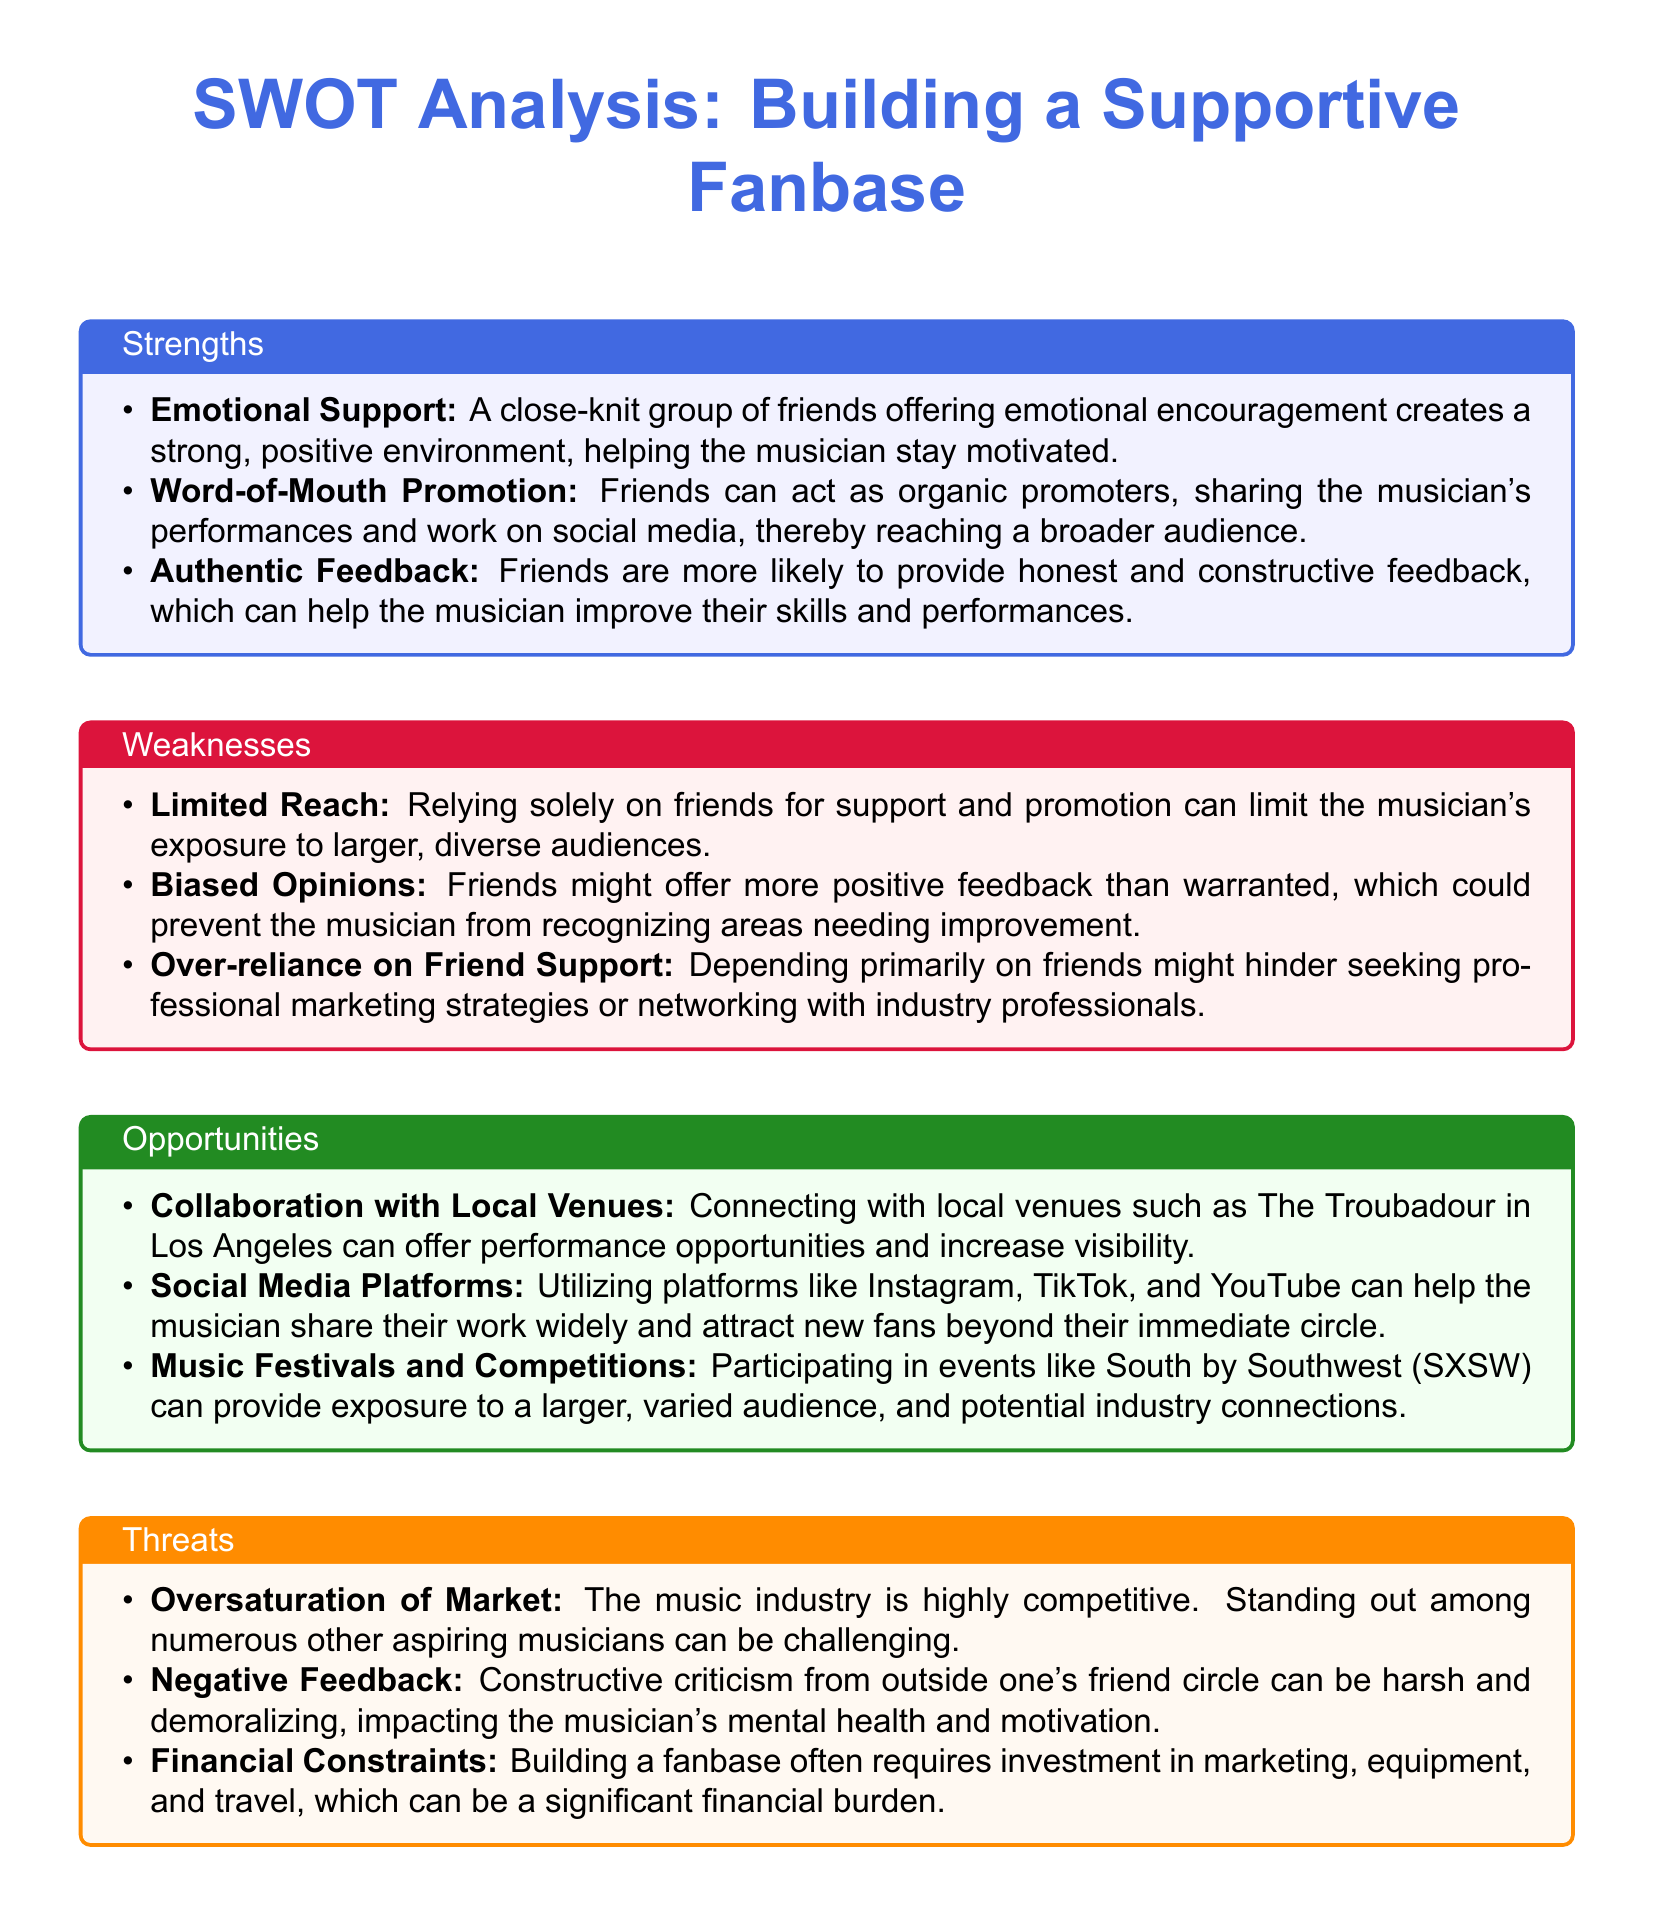What is one opportunity for building a supportive fanbase? The document lists several opportunities, one of which includes connecting with local venues for performance opportunities.
Answer: Connecting with local venues What is a weakness concerning friend support? One of the weaknesses highlights that relying solely on friends can limit exposure to larger, diverse audiences.
Answer: Limited Reach Name a strength that involves promotion. The document states that friends can act as organic promoters for sharing the musician's performances.
Answer: Word-of-Mouth Promotion What is a threat related to market conditions? The document mentions that the music industry is highly competitive, making it challenging to stand out among other musicians.
Answer: Oversaturation of Market How many opportunities are listed in the document? The document explicitly provides three opportunities for building a supportive fanbase.
Answer: Three What kind of feedback might friends provide? The weaknesses section mentions that friends might offer more positive feedback than warranted.
Answer: Biased Opinions Name a social media platform that can help attract new fans. The document refers to several platforms, including Instagram, TikTok, and YouTube, that can be utilized for broader outreach.
Answer: Instagram, TikTok, and YouTube What is one effect of negative feedback mentioned? The document indicates that constructive criticism from outside one's friend circle can impact mental health and motivation.
Answer: Impacting mental health and motivation What is a financial concern listed as a threat? One of the threats points out that building a fanbase often requires significant investment in marketing and travel.
Answer: Financial Constraints 